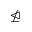<formula> <loc_0><loc_0><loc_500><loc_500>\ntrianglelefteq</formula> 